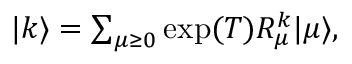<formula> <loc_0><loc_0><loc_500><loc_500>\begin{array} { r } { | k \rangle = \sum _ { \mu \geq 0 } \exp ( { T } ) R _ { \mu } ^ { k } | \mu \rangle , } \end{array}</formula> 